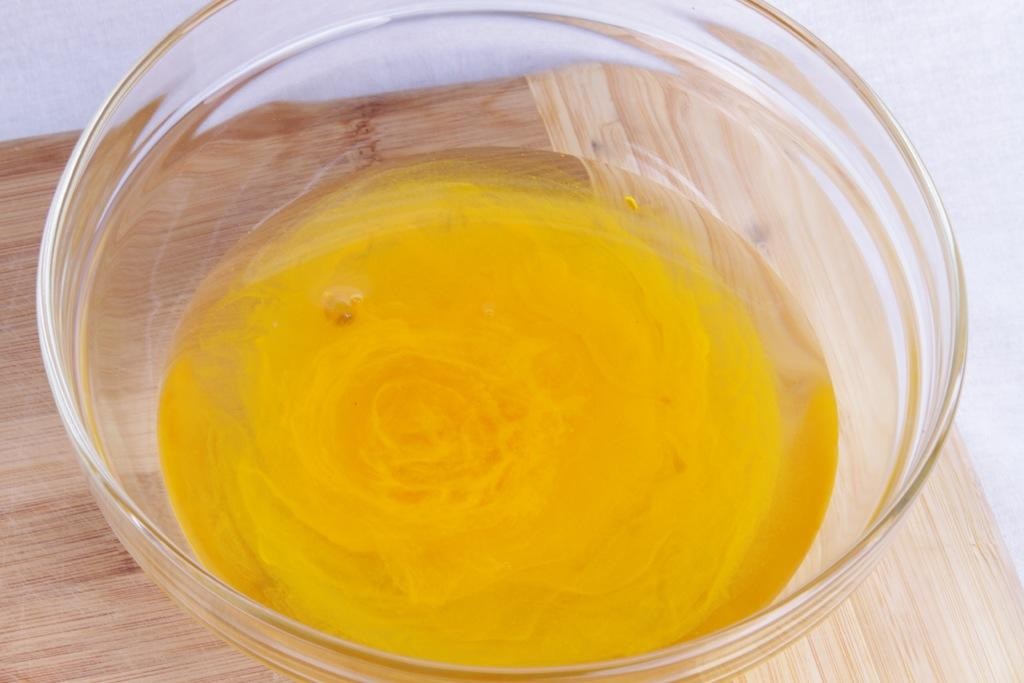What color is the liquid in the glass bowl in the image? The liquid in the glass bowl is yellow. What is the glass bowl placed on in the image? The glass bowl is on a brown color table. What type of fog can be seen surrounding the scarecrow in the image? There is no fog or scarecrow present in the image; it features a glass bowl with yellow liquid on a brown table. 